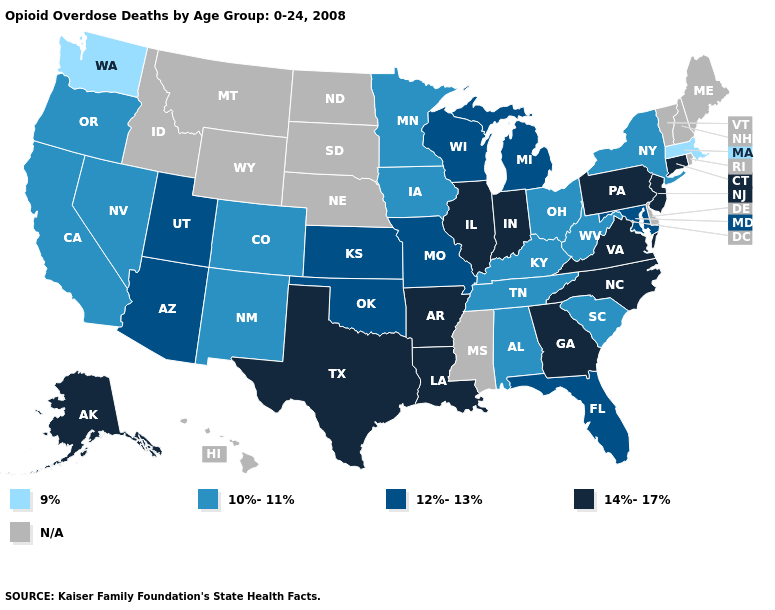What is the lowest value in the MidWest?
Short answer required. 10%-11%. Name the states that have a value in the range 12%-13%?
Be succinct. Arizona, Florida, Kansas, Maryland, Michigan, Missouri, Oklahoma, Utah, Wisconsin. Does North Carolina have the lowest value in the USA?
Give a very brief answer. No. What is the value of New Jersey?
Be succinct. 14%-17%. What is the value of Mississippi?
Short answer required. N/A. Does Washington have the lowest value in the West?
Short answer required. Yes. Which states have the highest value in the USA?
Short answer required. Alaska, Arkansas, Connecticut, Georgia, Illinois, Indiana, Louisiana, New Jersey, North Carolina, Pennsylvania, Texas, Virginia. Name the states that have a value in the range 10%-11%?
Be succinct. Alabama, California, Colorado, Iowa, Kentucky, Minnesota, Nevada, New Mexico, New York, Ohio, Oregon, South Carolina, Tennessee, West Virginia. Name the states that have a value in the range 14%-17%?
Give a very brief answer. Alaska, Arkansas, Connecticut, Georgia, Illinois, Indiana, Louisiana, New Jersey, North Carolina, Pennsylvania, Texas, Virginia. Name the states that have a value in the range N/A?
Give a very brief answer. Delaware, Hawaii, Idaho, Maine, Mississippi, Montana, Nebraska, New Hampshire, North Dakota, Rhode Island, South Dakota, Vermont, Wyoming. Name the states that have a value in the range 14%-17%?
Be succinct. Alaska, Arkansas, Connecticut, Georgia, Illinois, Indiana, Louisiana, New Jersey, North Carolina, Pennsylvania, Texas, Virginia. Which states have the lowest value in the Northeast?
Short answer required. Massachusetts. What is the lowest value in states that border Wyoming?
Answer briefly. 10%-11%. Name the states that have a value in the range 14%-17%?
Give a very brief answer. Alaska, Arkansas, Connecticut, Georgia, Illinois, Indiana, Louisiana, New Jersey, North Carolina, Pennsylvania, Texas, Virginia. 